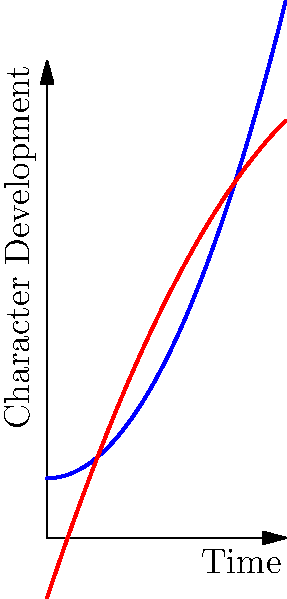In your latest story inspired by your parent's homeland, you've plotted the character development arcs for two main characters over time. The blue curve represents Character A's development, while the red curve represents Character B's. Based on the graph, at what point in time do both characters reach the same level of development? To find the point where both characters reach the same level of development, we need to determine where the two curves intersect. This involves the following steps:

1. Identify the equations for both curves:
   Character A (blue): $y = 0.5x^2 + 1$
   Character B (red): $y = -0.25x^2 + 3x - 1$

2. Set the equations equal to each other:
   $0.5x^2 + 1 = -0.25x^2 + 3x - 1$

3. Rearrange the equation:
   $0.75x^2 - 3x + 2 = 0$

4. This is a quadratic equation. We can solve it using the quadratic formula:
   $x = \frac{-b \pm \sqrt{b^2 - 4ac}}{2a}$

   Where $a = 0.75$, $b = -3$, and $c = 2$

5. Plugging these values into the quadratic formula:
   $x = \frac{3 \pm \sqrt{9 - 6}}{1.5} = \frac{3 \pm \sqrt{3}}{1.5}$

6. This gives us two solutions:
   $x_1 = \frac{3 + \sqrt{3}}{1.5} \approx 2.37$
   $x_2 = \frac{3 - \sqrt{3}}{1.5} \approx 0.63$

7. Looking at the graph, we can see that the curves intersect at a point between 2 and 3 on the x-axis.

Therefore, the characters reach the same level of development at approximately 2.37 time units.
Answer: 2.37 time units 